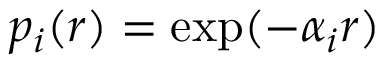<formula> <loc_0><loc_0><loc_500><loc_500>p _ { i } ( r ) = \exp ( - \alpha _ { i } r )</formula> 